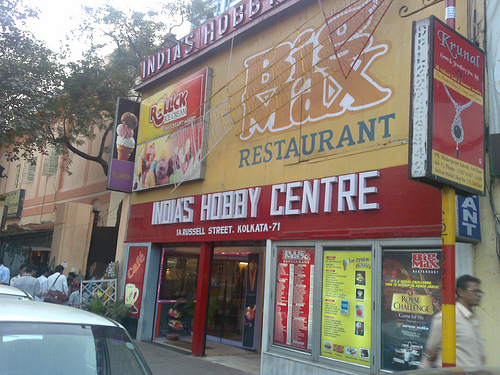<image>
Is the man behind the sign? Yes. From this viewpoint, the man is positioned behind the sign, with the sign partially or fully occluding the man. 